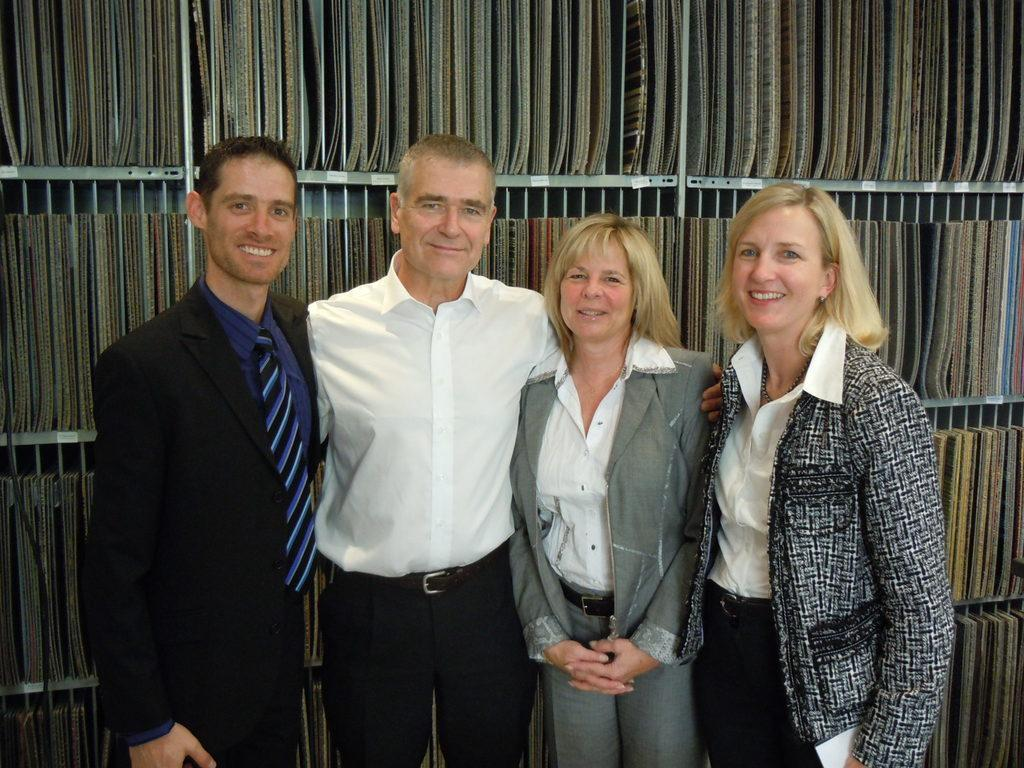How many people are in the image? There are four people in the image, two men and two women. What are the people in the image doing? The people are standing. What can be seen in the background of the image? There is a rack in the background of the image. What is on the rack? There are books on the rack. What type of flower is growing in the image? There is no flower present in the image. In which direction are the people facing in the image? The provided facts do not specify the direction the people are facing, so it cannot be determined from the image. 